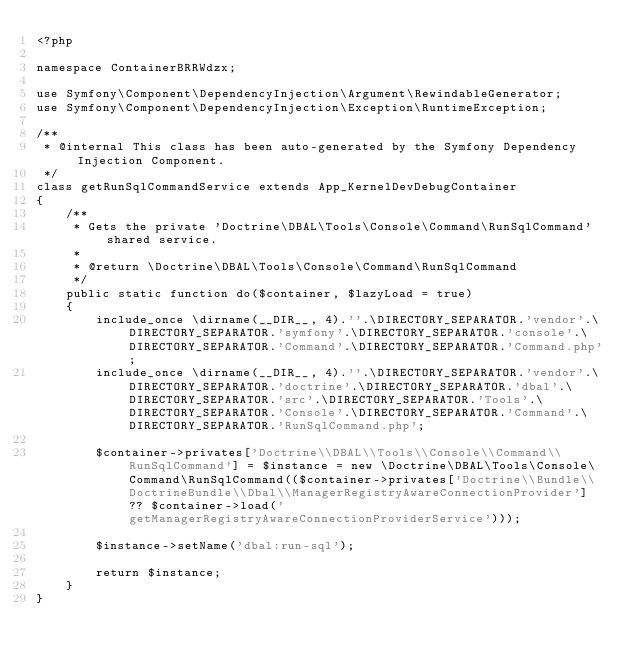Convert code to text. <code><loc_0><loc_0><loc_500><loc_500><_PHP_><?php

namespace ContainerBRRWdzx;

use Symfony\Component\DependencyInjection\Argument\RewindableGenerator;
use Symfony\Component\DependencyInjection\Exception\RuntimeException;

/**
 * @internal This class has been auto-generated by the Symfony Dependency Injection Component.
 */
class getRunSqlCommandService extends App_KernelDevDebugContainer
{
    /**
     * Gets the private 'Doctrine\DBAL\Tools\Console\Command\RunSqlCommand' shared service.
     *
     * @return \Doctrine\DBAL\Tools\Console\Command\RunSqlCommand
     */
    public static function do($container, $lazyLoad = true)
    {
        include_once \dirname(__DIR__, 4).''.\DIRECTORY_SEPARATOR.'vendor'.\DIRECTORY_SEPARATOR.'symfony'.\DIRECTORY_SEPARATOR.'console'.\DIRECTORY_SEPARATOR.'Command'.\DIRECTORY_SEPARATOR.'Command.php';
        include_once \dirname(__DIR__, 4).''.\DIRECTORY_SEPARATOR.'vendor'.\DIRECTORY_SEPARATOR.'doctrine'.\DIRECTORY_SEPARATOR.'dbal'.\DIRECTORY_SEPARATOR.'src'.\DIRECTORY_SEPARATOR.'Tools'.\DIRECTORY_SEPARATOR.'Console'.\DIRECTORY_SEPARATOR.'Command'.\DIRECTORY_SEPARATOR.'RunSqlCommand.php';

        $container->privates['Doctrine\\DBAL\\Tools\\Console\\Command\\RunSqlCommand'] = $instance = new \Doctrine\DBAL\Tools\Console\Command\RunSqlCommand(($container->privates['Doctrine\\Bundle\\DoctrineBundle\\Dbal\\ManagerRegistryAwareConnectionProvider'] ?? $container->load('getManagerRegistryAwareConnectionProviderService')));

        $instance->setName('dbal:run-sql');

        return $instance;
    }
}
</code> 